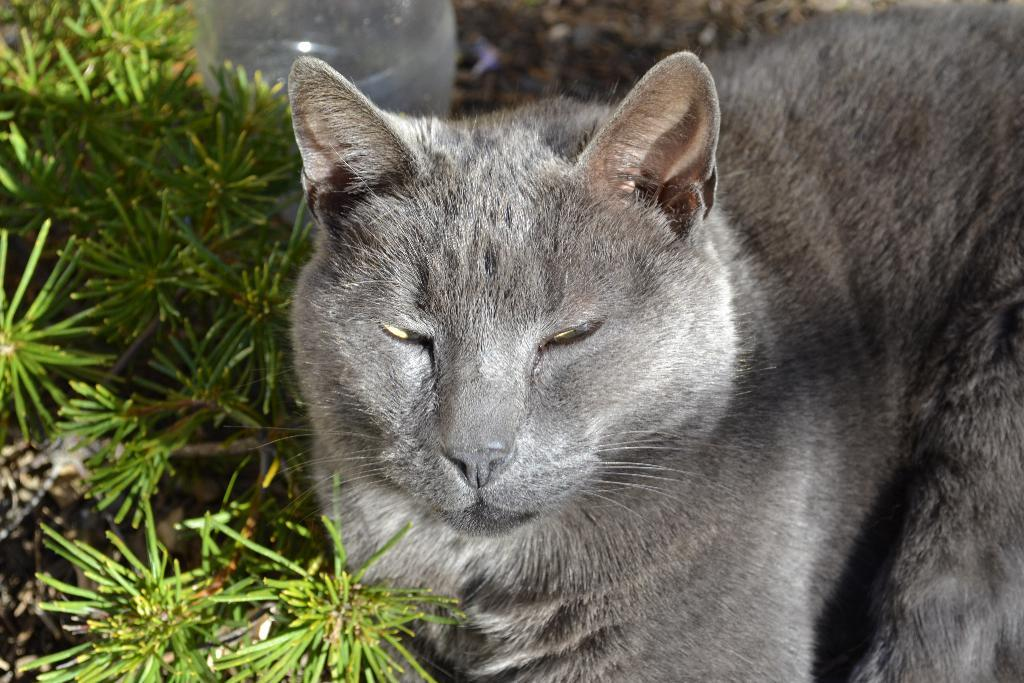What type of animal is in the image? There is a cat in the image. What color is the cat? The cat is grey in color. What can be seen on the left side of the image? There are plants on the left side of the image. Where is the river located in the image? There is no river present in the image. How does the cat push the argument in the image? The image does not depict an argument or any interaction between the cat and an argument. 